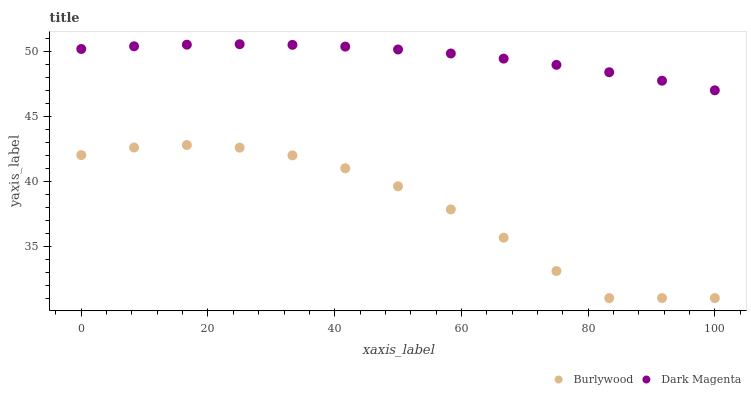Does Burlywood have the minimum area under the curve?
Answer yes or no. Yes. Does Dark Magenta have the maximum area under the curve?
Answer yes or no. Yes. Does Dark Magenta have the minimum area under the curve?
Answer yes or no. No. Is Dark Magenta the smoothest?
Answer yes or no. Yes. Is Burlywood the roughest?
Answer yes or no. Yes. Is Dark Magenta the roughest?
Answer yes or no. No. Does Burlywood have the lowest value?
Answer yes or no. Yes. Does Dark Magenta have the lowest value?
Answer yes or no. No. Does Dark Magenta have the highest value?
Answer yes or no. Yes. Is Burlywood less than Dark Magenta?
Answer yes or no. Yes. Is Dark Magenta greater than Burlywood?
Answer yes or no. Yes. Does Burlywood intersect Dark Magenta?
Answer yes or no. No. 